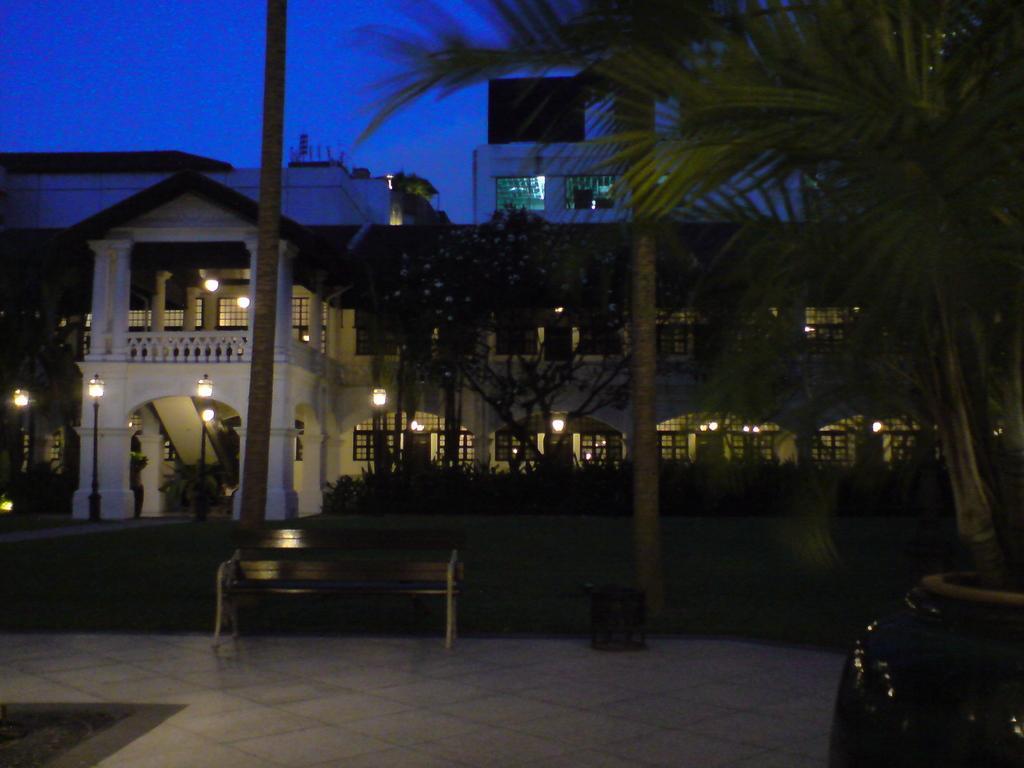How would you summarize this image in a sentence or two? In the center of the image there is a bench. There is a bin. At the bottom of the image there is floor. In the background of the image there is house. There are trees. There is grass. At the top of the image there is sky. 